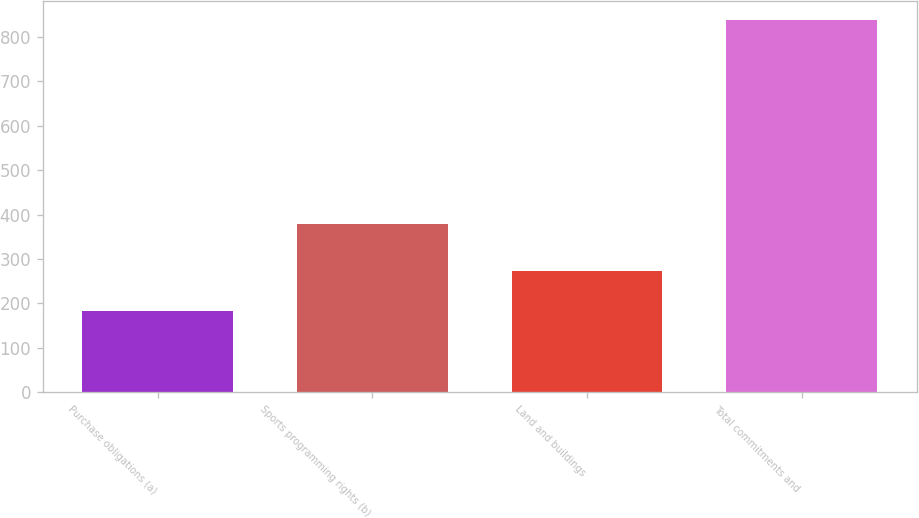<chart> <loc_0><loc_0><loc_500><loc_500><bar_chart><fcel>Purchase obligations (a)<fcel>Sports programming rights (b)<fcel>Land and buildings<fcel>Total commitments and<nl><fcel>183<fcel>379<fcel>274<fcel>838<nl></chart> 